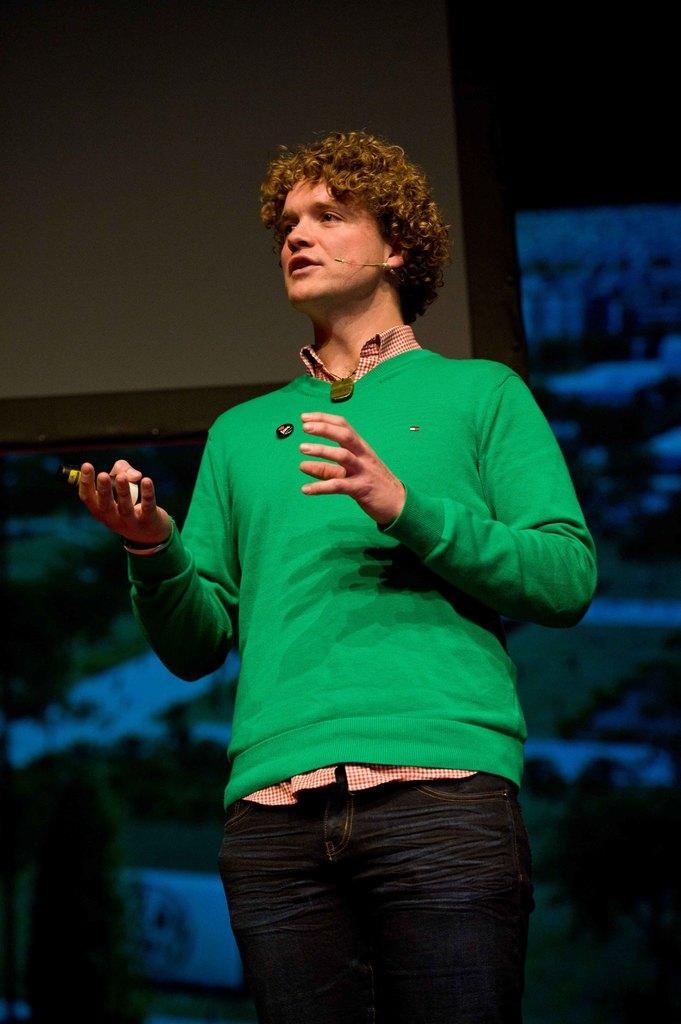Who or what is present in the image? There is a person in the image. What is the person wearing? The person is wearing a mic. What is the person holding in their hand? The person is holding something in their hand. What can be seen in the background of the image? There is a wall in the background of the image. How would you describe the lighting in the image? The environment is dark. What type of throne can be seen in the image? There is no throne present in the image. What thoughts does the person in the image have about the ongoing war? The image does not provide any information about the person's thoughts or the existence of a war. 